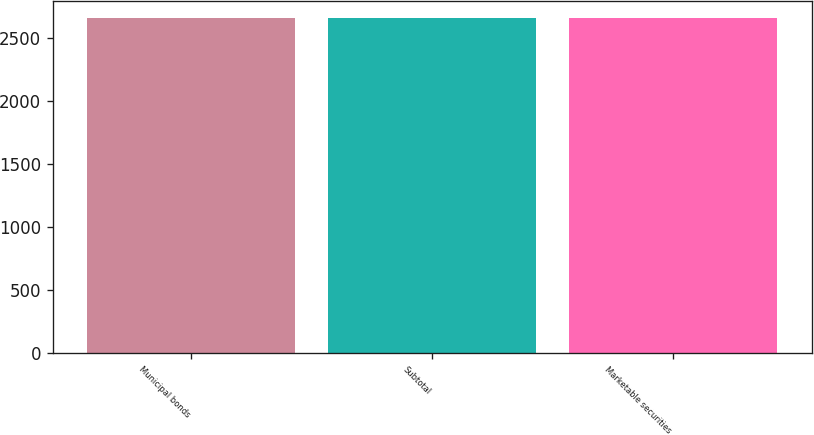Convert chart. <chart><loc_0><loc_0><loc_500><loc_500><bar_chart><fcel>Municipal bonds<fcel>Subtotal<fcel>Marketable securities<nl><fcel>2661<fcel>2661.1<fcel>2661.2<nl></chart> 